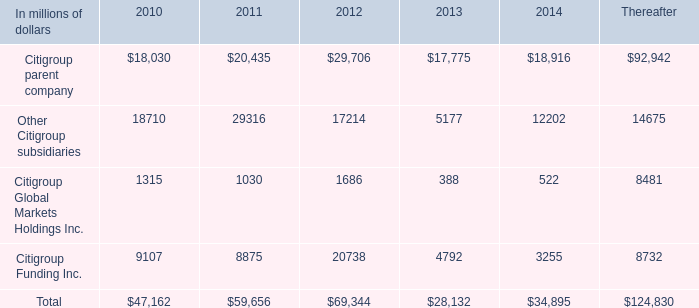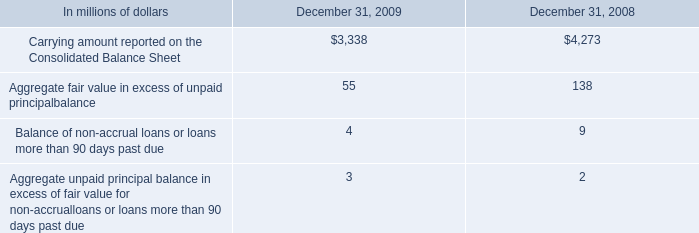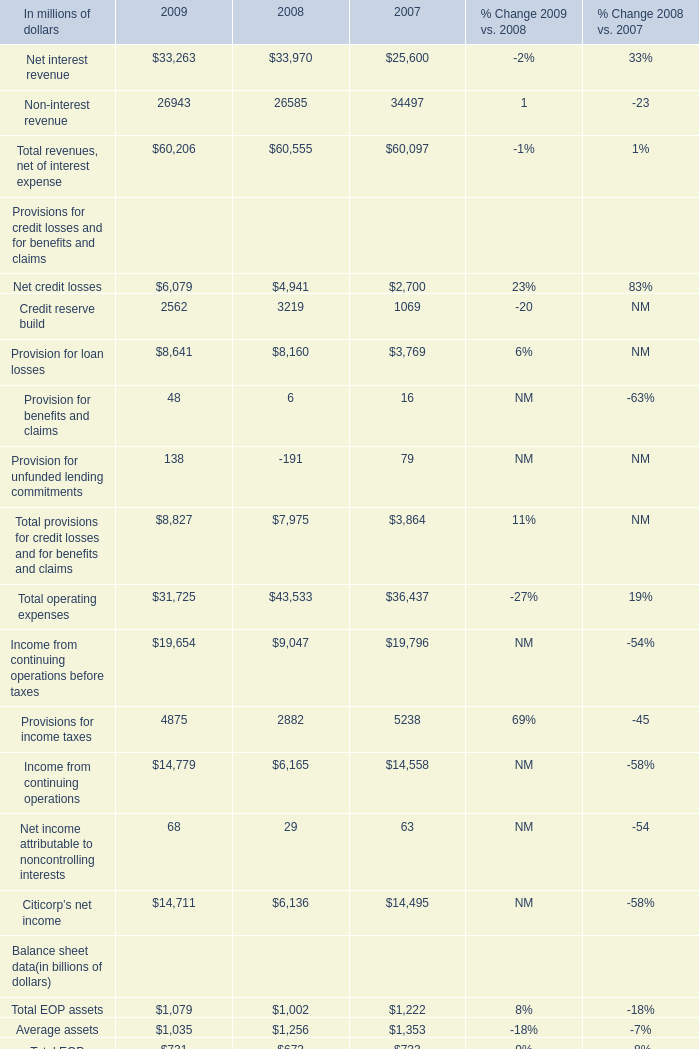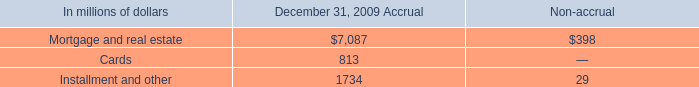What's the sum of Citigroup parent company of 2011, and Mortgage and real estate of December 31, 2009 Accrual ? 
Computations: (20435.0 + 7087.0)
Answer: 27522.0. 